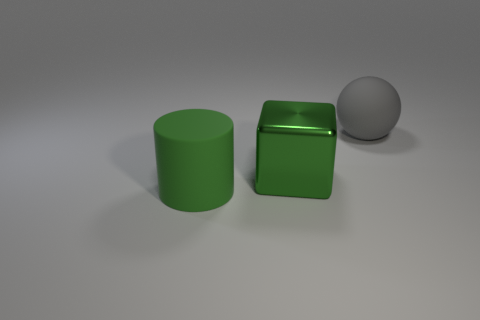Add 2 green metallic cubes. How many objects exist? 5 Subtract all blocks. How many objects are left? 2 Add 3 big green matte objects. How many big green matte objects are left? 4 Add 2 tiny brown metallic cylinders. How many tiny brown metallic cylinders exist? 2 Subtract 0 brown cubes. How many objects are left? 3 Subtract all tiny yellow metallic objects. Subtract all large metallic objects. How many objects are left? 2 